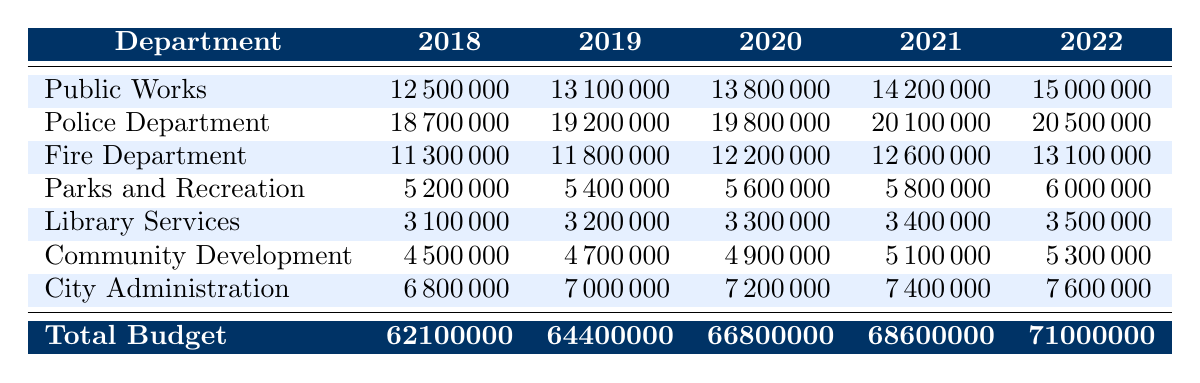What was the budget for the Police Department in 2021? According to the table, the budget for the Police Department for the year 2021 is listed directly in the relevant cell.
Answer: 20100000 What is the total budget for all departments in 2022? The total budget for all departments in the year 2022 is specifically indicated in the table.
Answer: 71000000 Which department had the highest budget in 2019? To find the department with the highest budget in 2019, we compare all the budgets listed for that year. The Police Department has the highest budget of 19200000.
Answer: Police Department What was the increase in the budget for Public Works from 2018 to 2022? The budget for Public Works in 2018 was 12500000 and in 2022 it is 15000000. To find the increase, subtract the 2018 budget from the 2022 budget: 15000000 - 12500000 = 2500000.
Answer: 2500000 Is the budget for the Library Services increasing over the years? By looking at the data for Library Services from 2018 (3100000) to 2022 (3500000) we can see that the budget has increased every year. Yes, the budget is increasing.
Answer: Yes What is the average budget for the Fire Department over the five years? We need to sum the budgets for the Fire Department from each year (11300000 + 11800000 + 12200000 + 12600000 + 13100000 = 61000000) and then divide by the number of years (5). So, 61000000 / 5 = 12200000.
Answer: 12200000 Which department received the smallest budget in 2020? To determine which department had the smallest budget in 2020, we look at each value for that year. Parks and Recreation had the smallest budget of 5600000.
Answer: Parks and Recreation What was the total budget increase from 2018 to 2022? To find the total budget increase, we take the 2022 total budget (71000000) and subtract the 2018 total budget (62100000): 71000000 - 62100000 = 8900000.
Answer: 8900000 In which year did Community Development have a budget equal to or greater than 5000000 for the first time? Looking at the Community Development budget over the years: in 2018 it was 4500000, in 2019 it was 4700000, in 2020 it was 4900000, and in 2021 it reached 5100000. Therefore, the first year it reached or surpassed 5000000 is 2021.
Answer: 2021 